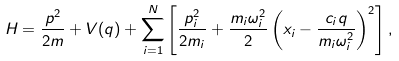Convert formula to latex. <formula><loc_0><loc_0><loc_500><loc_500>H = \frac { p ^ { 2 } } { 2 m } + V ( q ) + \sum _ { i = 1 } ^ { N } \left [ \frac { p _ { i } ^ { 2 } } { 2 m _ { i } } + \frac { m _ { i } \omega _ { i } ^ { 2 } } { 2 } \left ( x _ { i } - \frac { c _ { i } q } { m _ { i } \omega _ { i } ^ { 2 } } \right ) ^ { 2 } \right ] ,</formula> 